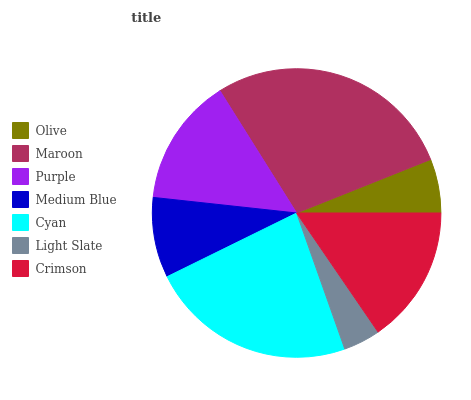Is Light Slate the minimum?
Answer yes or no. Yes. Is Maroon the maximum?
Answer yes or no. Yes. Is Purple the minimum?
Answer yes or no. No. Is Purple the maximum?
Answer yes or no. No. Is Maroon greater than Purple?
Answer yes or no. Yes. Is Purple less than Maroon?
Answer yes or no. Yes. Is Purple greater than Maroon?
Answer yes or no. No. Is Maroon less than Purple?
Answer yes or no. No. Is Purple the high median?
Answer yes or no. Yes. Is Purple the low median?
Answer yes or no. Yes. Is Medium Blue the high median?
Answer yes or no. No. Is Olive the low median?
Answer yes or no. No. 